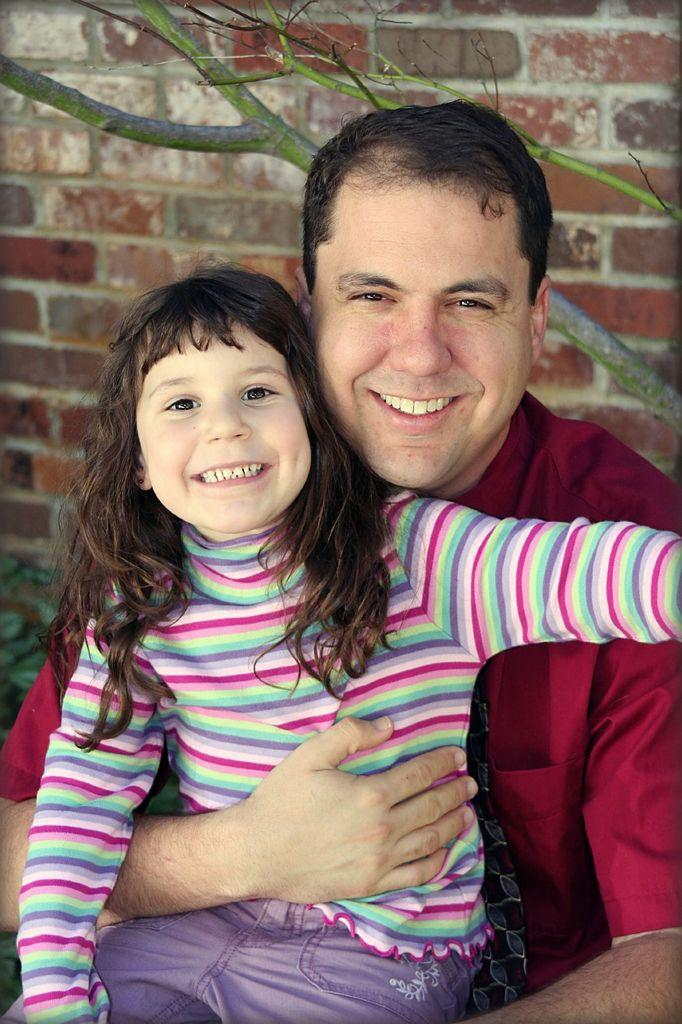Who is present in the image? There is a man in the image. What is the man doing in the image? The man is holding a girl. How are the man and the girl feeling in the image? Both the man and the girl are smiling. What can be seen in the background of the image? There is a plant, a branch of a tree, and a brick wall in the background of the image. What type of cabbage is being used as a seat for the man and the girl in the image? There is no cabbage present in the image; it features a man holding a girl with a background of a plant, a branch of a tree, and a brick wall. 